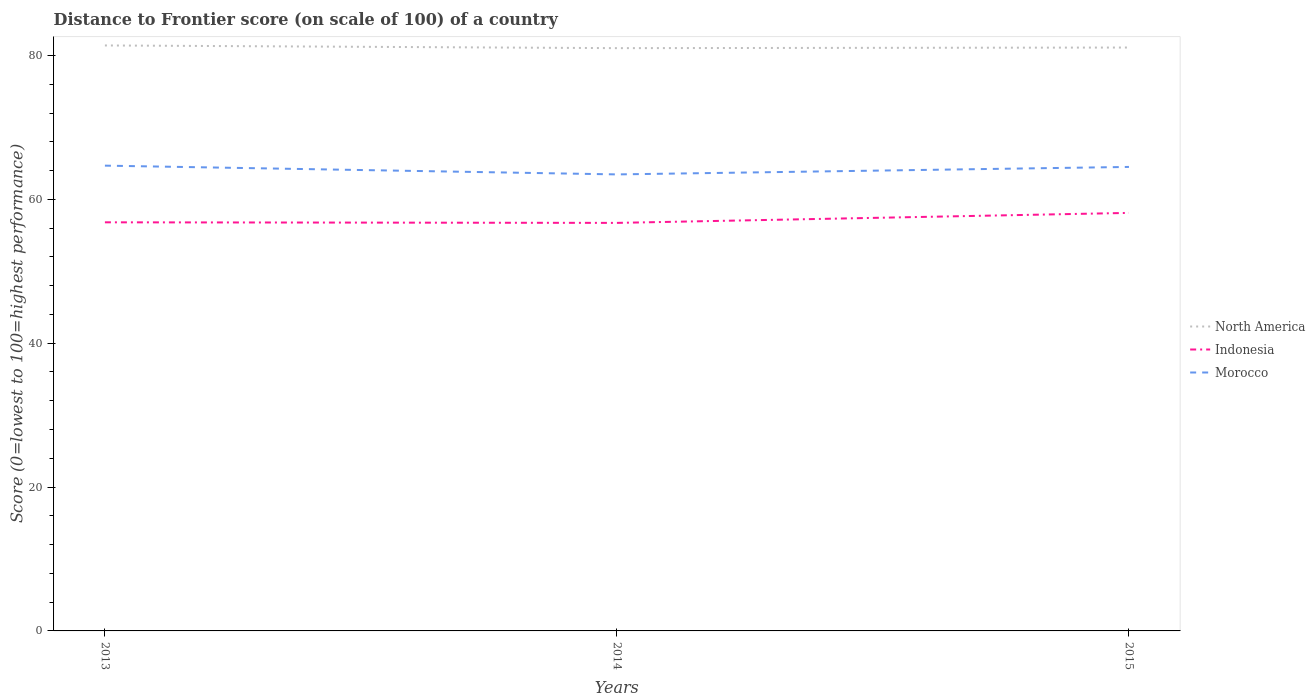How many different coloured lines are there?
Provide a short and direct response. 3. Does the line corresponding to Morocco intersect with the line corresponding to North America?
Keep it short and to the point. No. Is the number of lines equal to the number of legend labels?
Offer a very short reply. Yes. Across all years, what is the maximum distance to frontier score of in Indonesia?
Your response must be concise. 56.73. What is the total distance to frontier score of in North America in the graph?
Your response must be concise. -0.08. What is the difference between the highest and the second highest distance to frontier score of in North America?
Your response must be concise. 0.38. Is the distance to frontier score of in Morocco strictly greater than the distance to frontier score of in Indonesia over the years?
Offer a very short reply. No. How many lines are there?
Ensure brevity in your answer.  3. Are the values on the major ticks of Y-axis written in scientific E-notation?
Ensure brevity in your answer.  No. Does the graph contain any zero values?
Keep it short and to the point. No. What is the title of the graph?
Give a very brief answer. Distance to Frontier score (on scale of 100) of a country. What is the label or title of the X-axis?
Offer a terse response. Years. What is the label or title of the Y-axis?
Offer a terse response. Score (0=lowest to 100=highest performance). What is the Score (0=lowest to 100=highest performance) of North America in 2013?
Provide a short and direct response. 81.4. What is the Score (0=lowest to 100=highest performance) of Indonesia in 2013?
Offer a terse response. 56.81. What is the Score (0=lowest to 100=highest performance) of Morocco in 2013?
Keep it short and to the point. 64.69. What is the Score (0=lowest to 100=highest performance) of North America in 2014?
Provide a succinct answer. 81.03. What is the Score (0=lowest to 100=highest performance) in Indonesia in 2014?
Provide a succinct answer. 56.73. What is the Score (0=lowest to 100=highest performance) in Morocco in 2014?
Offer a terse response. 63.47. What is the Score (0=lowest to 100=highest performance) in North America in 2015?
Your answer should be compact. 81.11. What is the Score (0=lowest to 100=highest performance) in Indonesia in 2015?
Provide a succinct answer. 58.12. What is the Score (0=lowest to 100=highest performance) of Morocco in 2015?
Ensure brevity in your answer.  64.51. Across all years, what is the maximum Score (0=lowest to 100=highest performance) of North America?
Offer a terse response. 81.4. Across all years, what is the maximum Score (0=lowest to 100=highest performance) in Indonesia?
Offer a very short reply. 58.12. Across all years, what is the maximum Score (0=lowest to 100=highest performance) in Morocco?
Your answer should be compact. 64.69. Across all years, what is the minimum Score (0=lowest to 100=highest performance) of North America?
Offer a very short reply. 81.03. Across all years, what is the minimum Score (0=lowest to 100=highest performance) in Indonesia?
Provide a short and direct response. 56.73. Across all years, what is the minimum Score (0=lowest to 100=highest performance) of Morocco?
Provide a succinct answer. 63.47. What is the total Score (0=lowest to 100=highest performance) of North America in the graph?
Give a very brief answer. 243.53. What is the total Score (0=lowest to 100=highest performance) of Indonesia in the graph?
Provide a succinct answer. 171.66. What is the total Score (0=lowest to 100=highest performance) of Morocco in the graph?
Offer a very short reply. 192.67. What is the difference between the Score (0=lowest to 100=highest performance) of Indonesia in 2013 and that in 2014?
Offer a very short reply. 0.08. What is the difference between the Score (0=lowest to 100=highest performance) of Morocco in 2013 and that in 2014?
Make the answer very short. 1.22. What is the difference between the Score (0=lowest to 100=highest performance) in North America in 2013 and that in 2015?
Make the answer very short. 0.29. What is the difference between the Score (0=lowest to 100=highest performance) in Indonesia in 2013 and that in 2015?
Offer a terse response. -1.31. What is the difference between the Score (0=lowest to 100=highest performance) in Morocco in 2013 and that in 2015?
Your answer should be compact. 0.18. What is the difference between the Score (0=lowest to 100=highest performance) of North America in 2014 and that in 2015?
Keep it short and to the point. -0.09. What is the difference between the Score (0=lowest to 100=highest performance) of Indonesia in 2014 and that in 2015?
Give a very brief answer. -1.39. What is the difference between the Score (0=lowest to 100=highest performance) in Morocco in 2014 and that in 2015?
Keep it short and to the point. -1.04. What is the difference between the Score (0=lowest to 100=highest performance) in North America in 2013 and the Score (0=lowest to 100=highest performance) in Indonesia in 2014?
Provide a succinct answer. 24.67. What is the difference between the Score (0=lowest to 100=highest performance) of North America in 2013 and the Score (0=lowest to 100=highest performance) of Morocco in 2014?
Offer a very short reply. 17.93. What is the difference between the Score (0=lowest to 100=highest performance) of Indonesia in 2013 and the Score (0=lowest to 100=highest performance) of Morocco in 2014?
Make the answer very short. -6.66. What is the difference between the Score (0=lowest to 100=highest performance) of North America in 2013 and the Score (0=lowest to 100=highest performance) of Indonesia in 2015?
Make the answer very short. 23.28. What is the difference between the Score (0=lowest to 100=highest performance) of North America in 2013 and the Score (0=lowest to 100=highest performance) of Morocco in 2015?
Your answer should be compact. 16.89. What is the difference between the Score (0=lowest to 100=highest performance) of North America in 2014 and the Score (0=lowest to 100=highest performance) of Indonesia in 2015?
Provide a succinct answer. 22.91. What is the difference between the Score (0=lowest to 100=highest performance) of North America in 2014 and the Score (0=lowest to 100=highest performance) of Morocco in 2015?
Your answer should be compact. 16.52. What is the difference between the Score (0=lowest to 100=highest performance) in Indonesia in 2014 and the Score (0=lowest to 100=highest performance) in Morocco in 2015?
Your answer should be compact. -7.78. What is the average Score (0=lowest to 100=highest performance) of North America per year?
Your answer should be compact. 81.18. What is the average Score (0=lowest to 100=highest performance) of Indonesia per year?
Ensure brevity in your answer.  57.22. What is the average Score (0=lowest to 100=highest performance) of Morocco per year?
Ensure brevity in your answer.  64.22. In the year 2013, what is the difference between the Score (0=lowest to 100=highest performance) of North America and Score (0=lowest to 100=highest performance) of Indonesia?
Provide a succinct answer. 24.59. In the year 2013, what is the difference between the Score (0=lowest to 100=highest performance) of North America and Score (0=lowest to 100=highest performance) of Morocco?
Ensure brevity in your answer.  16.71. In the year 2013, what is the difference between the Score (0=lowest to 100=highest performance) in Indonesia and Score (0=lowest to 100=highest performance) in Morocco?
Provide a short and direct response. -7.88. In the year 2014, what is the difference between the Score (0=lowest to 100=highest performance) in North America and Score (0=lowest to 100=highest performance) in Indonesia?
Your response must be concise. 24.3. In the year 2014, what is the difference between the Score (0=lowest to 100=highest performance) of North America and Score (0=lowest to 100=highest performance) of Morocco?
Offer a terse response. 17.55. In the year 2014, what is the difference between the Score (0=lowest to 100=highest performance) in Indonesia and Score (0=lowest to 100=highest performance) in Morocco?
Your answer should be compact. -6.74. In the year 2015, what is the difference between the Score (0=lowest to 100=highest performance) of North America and Score (0=lowest to 100=highest performance) of Indonesia?
Give a very brief answer. 22.99. In the year 2015, what is the difference between the Score (0=lowest to 100=highest performance) of North America and Score (0=lowest to 100=highest performance) of Morocco?
Provide a short and direct response. 16.6. In the year 2015, what is the difference between the Score (0=lowest to 100=highest performance) in Indonesia and Score (0=lowest to 100=highest performance) in Morocco?
Your answer should be very brief. -6.39. What is the ratio of the Score (0=lowest to 100=highest performance) in Indonesia in 2013 to that in 2014?
Keep it short and to the point. 1. What is the ratio of the Score (0=lowest to 100=highest performance) in Morocco in 2013 to that in 2014?
Provide a short and direct response. 1.02. What is the ratio of the Score (0=lowest to 100=highest performance) of North America in 2013 to that in 2015?
Give a very brief answer. 1. What is the ratio of the Score (0=lowest to 100=highest performance) in Indonesia in 2013 to that in 2015?
Give a very brief answer. 0.98. What is the ratio of the Score (0=lowest to 100=highest performance) in Morocco in 2013 to that in 2015?
Make the answer very short. 1. What is the ratio of the Score (0=lowest to 100=highest performance) of Indonesia in 2014 to that in 2015?
Offer a terse response. 0.98. What is the ratio of the Score (0=lowest to 100=highest performance) in Morocco in 2014 to that in 2015?
Offer a very short reply. 0.98. What is the difference between the highest and the second highest Score (0=lowest to 100=highest performance) of North America?
Provide a succinct answer. 0.29. What is the difference between the highest and the second highest Score (0=lowest to 100=highest performance) in Indonesia?
Offer a terse response. 1.31. What is the difference between the highest and the second highest Score (0=lowest to 100=highest performance) of Morocco?
Keep it short and to the point. 0.18. What is the difference between the highest and the lowest Score (0=lowest to 100=highest performance) of Indonesia?
Your answer should be very brief. 1.39. What is the difference between the highest and the lowest Score (0=lowest to 100=highest performance) of Morocco?
Give a very brief answer. 1.22. 